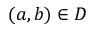Convert formula to latex. <formula><loc_0><loc_0><loc_500><loc_500>( a , b ) \in D</formula> 